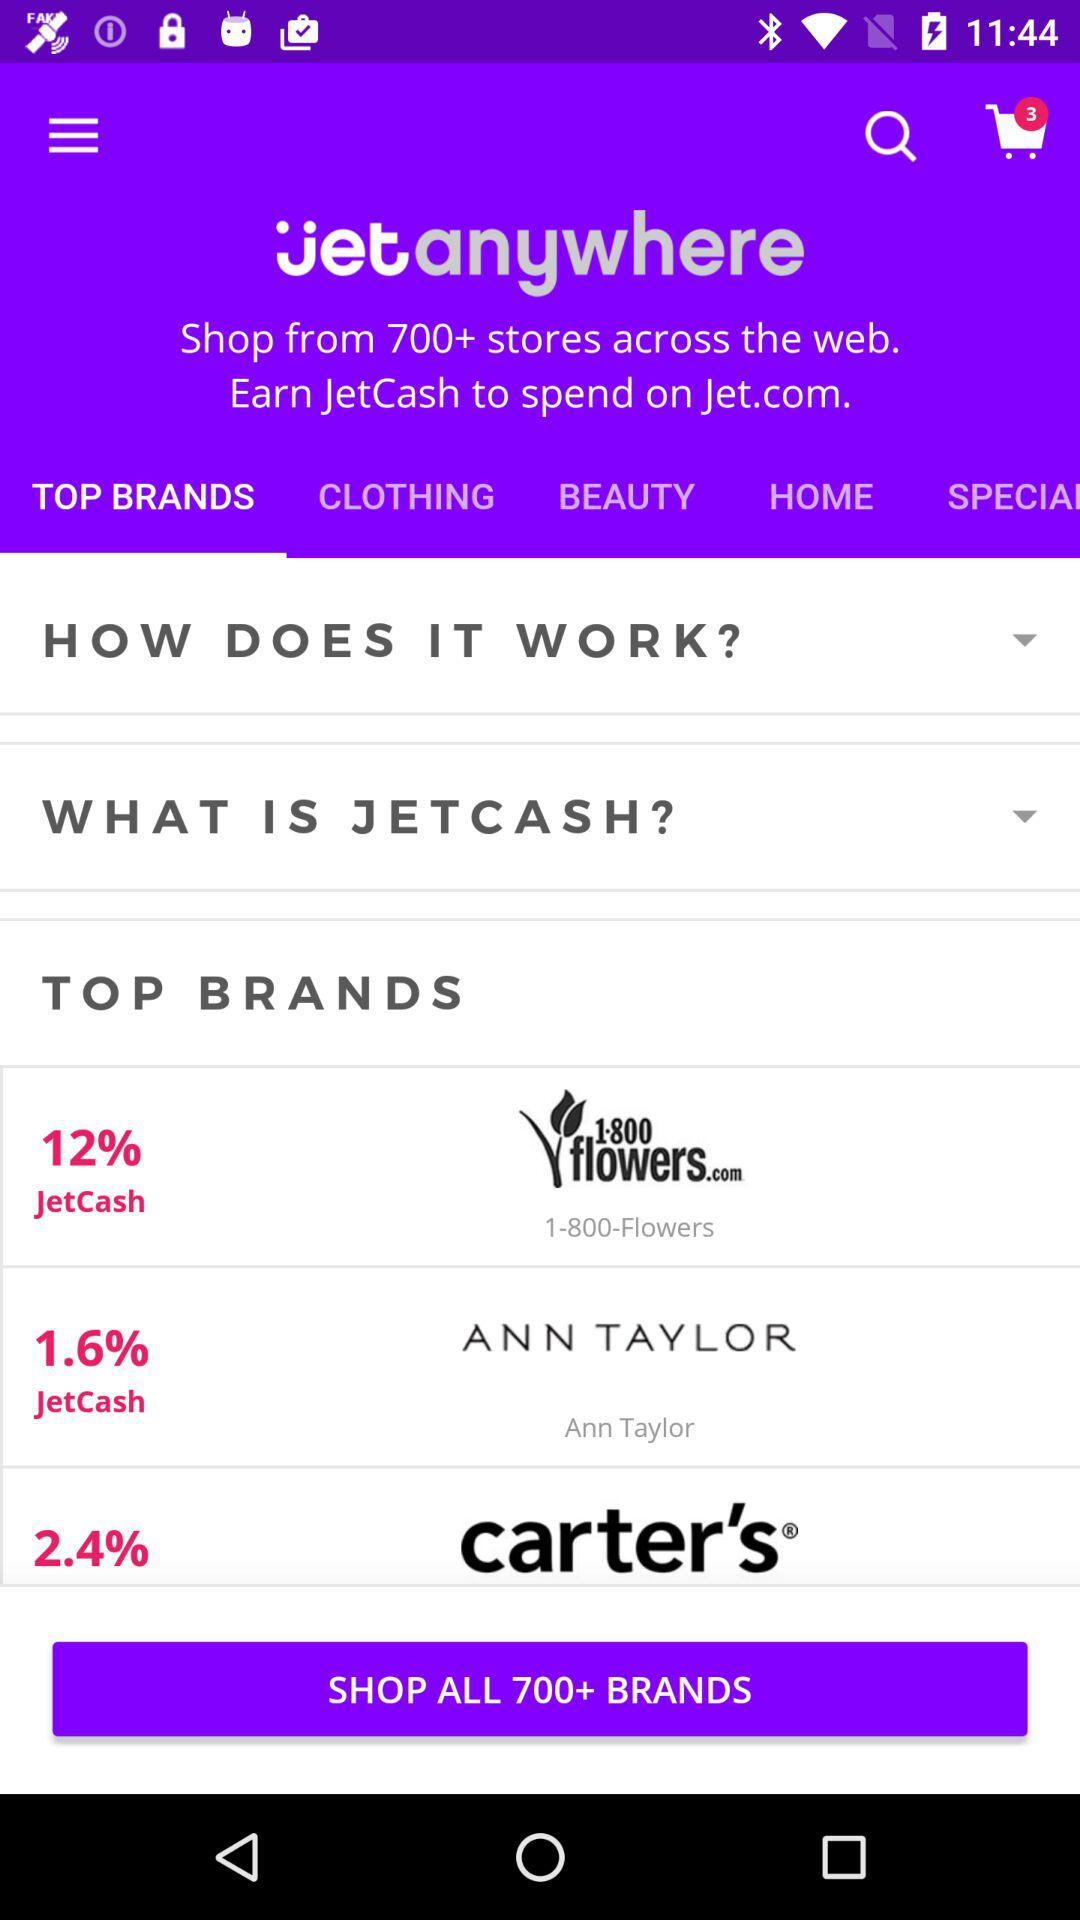How many brands offer more than 2% JetCash?
Answer the question using a single word or phrase. 2 